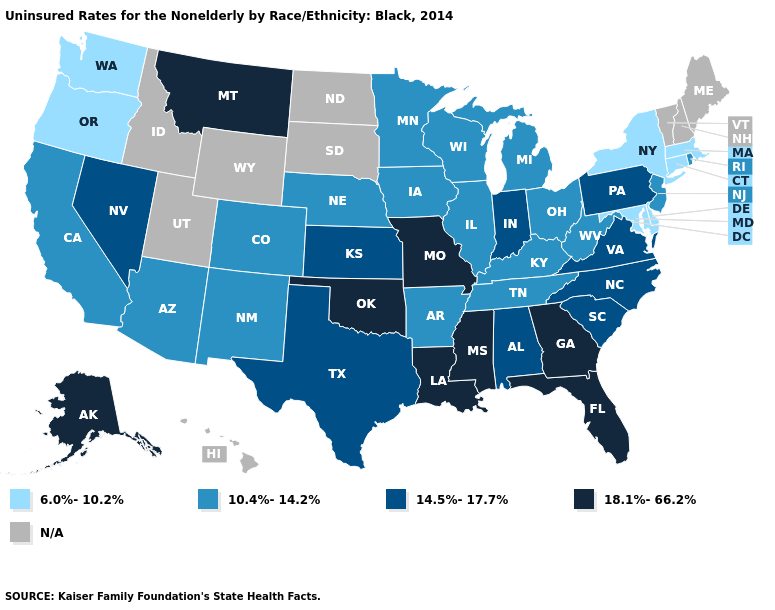Name the states that have a value in the range 10.4%-14.2%?
Be succinct. Arizona, Arkansas, California, Colorado, Illinois, Iowa, Kentucky, Michigan, Minnesota, Nebraska, New Jersey, New Mexico, Ohio, Rhode Island, Tennessee, West Virginia, Wisconsin. What is the highest value in the MidWest ?
Concise answer only. 18.1%-66.2%. What is the highest value in the West ?
Write a very short answer. 18.1%-66.2%. Is the legend a continuous bar?
Keep it brief. No. Which states hav the highest value in the Northeast?
Answer briefly. Pennsylvania. Among the states that border West Virginia , which have the lowest value?
Keep it brief. Maryland. What is the highest value in states that border West Virginia?
Give a very brief answer. 14.5%-17.7%. Which states have the lowest value in the USA?
Answer briefly. Connecticut, Delaware, Maryland, Massachusetts, New York, Oregon, Washington. What is the lowest value in the USA?
Keep it brief. 6.0%-10.2%. Does the first symbol in the legend represent the smallest category?
Be succinct. Yes. Which states hav the highest value in the Northeast?
Answer briefly. Pennsylvania. Which states have the lowest value in the USA?
Write a very short answer. Connecticut, Delaware, Maryland, Massachusetts, New York, Oregon, Washington. Name the states that have a value in the range 6.0%-10.2%?
Quick response, please. Connecticut, Delaware, Maryland, Massachusetts, New York, Oregon, Washington. Name the states that have a value in the range 6.0%-10.2%?
Short answer required. Connecticut, Delaware, Maryland, Massachusetts, New York, Oregon, Washington. 